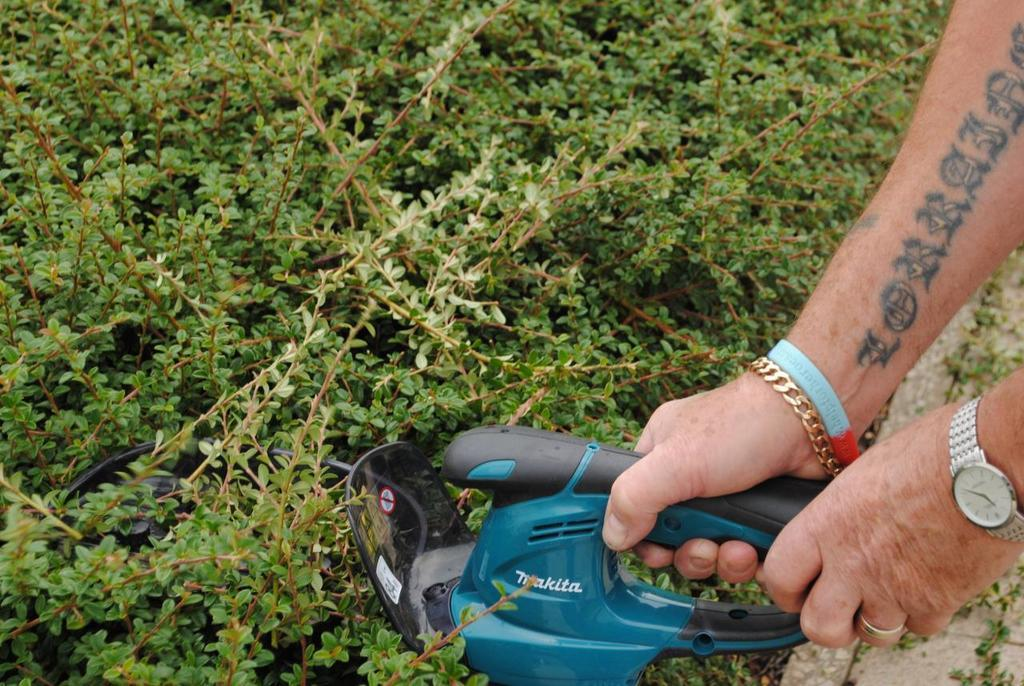What is the person in the image doing? The person is holding an object in the image. Where is the person located in the image? The person is on the right side of the image. What can be seen in the background of the image? There are plants in the background of the image. What type of question is being asked by the person in the image? There is no indication in the image that the person is asking a question. 